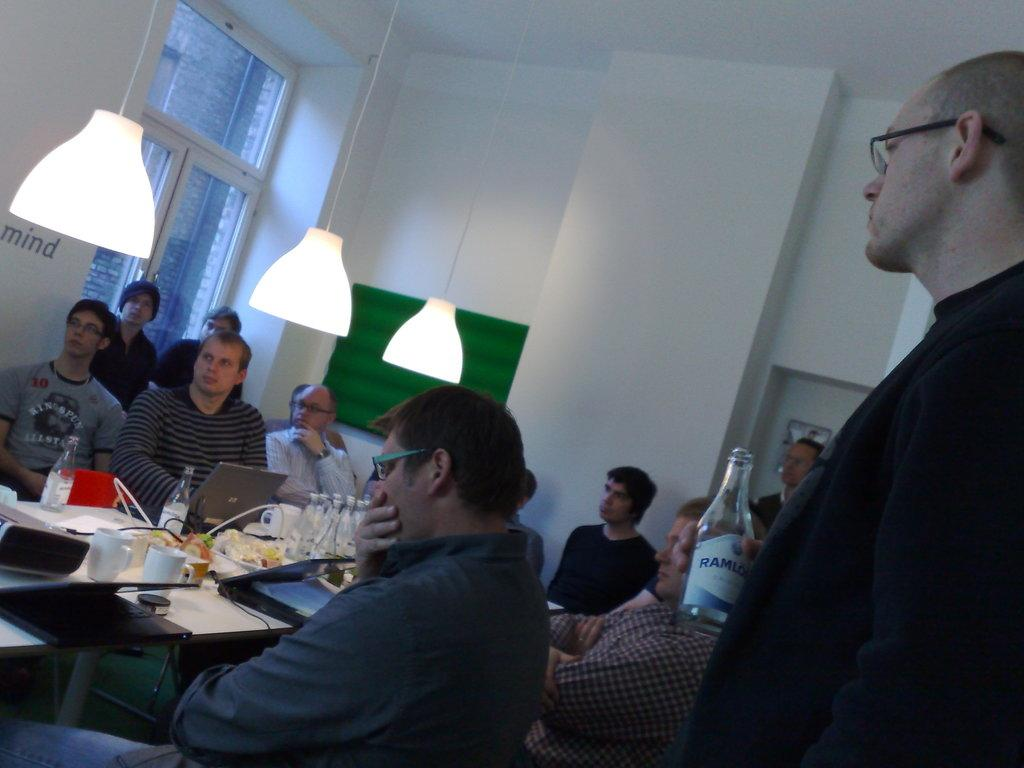What is the color of the wall in the image? The wall in the image is white. What can be seen on the wall in the image? There is a window on the wall in the image. What is present in the room that provides illumination? There are lights in the image. What are the people in the image doing? The people in the image are sitting on chairs. What furniture is present in the image? There is a table in the image. What items are on the table in the image? There are trees, bottles, cups, and plates on the table in the image. Is there a throne in the image? No, there is no throne present in the image. What type of lunch is being served on the plates in the image? There is no lunch being served in the image; it only shows trees, bottles, cups, and plates on the table. 